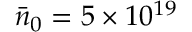<formula> <loc_0><loc_0><loc_500><loc_500>\bar { n } _ { 0 } = 5 \times 1 0 ^ { 1 9 }</formula> 